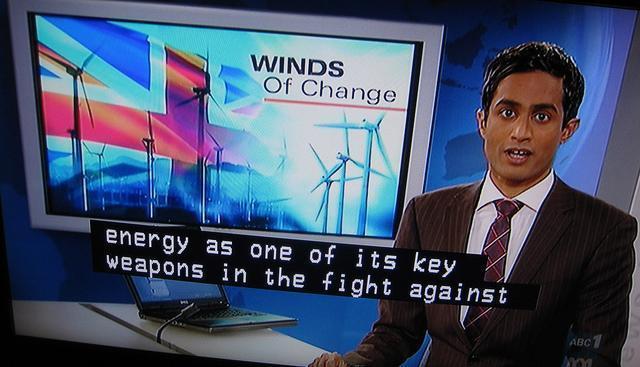Which national flag is in the segment screen of this broadcast?
Select the correct answer and articulate reasoning with the following format: 'Answer: answer
Rationale: rationale.'
Options: France, uk, netherlands, german. Answer: uk.
Rationale: The flag that is depicted is from the uk. 